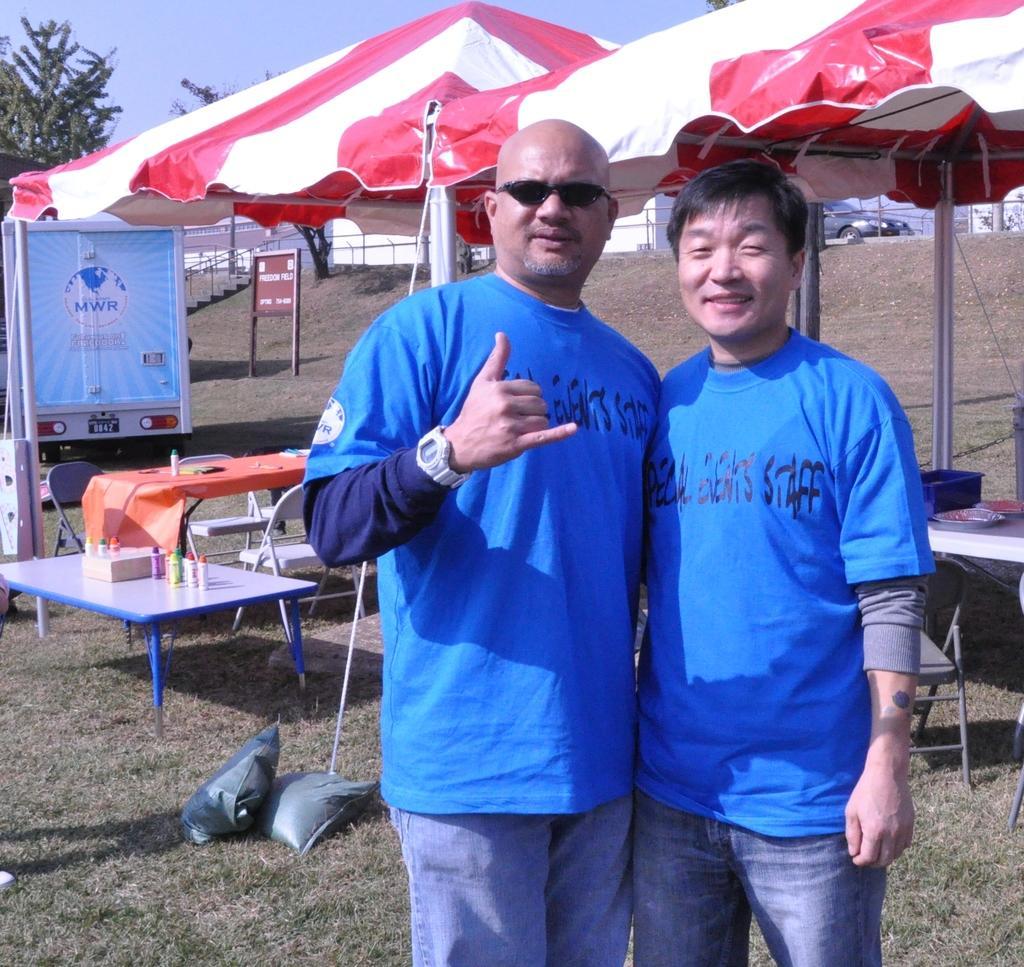In one or two sentences, can you explain what this image depicts? This picture is clicked outside the city. Man on the right corner of the picture wearing blue t-shirt and blue jeans is laughing. Beside him, we see men in blue t-shirt is wearing watch and also goggles. Behind him, we see table with orange cover on it and beside that, we see table on which glue sticks are placed and behind that, we see a vehicle on which 'MWR' is written on it. In the right top of the picture, we see a tent which is in white and red color. Behind that, we see car moving on the road and on the left corner of the picture, we see a tree. 